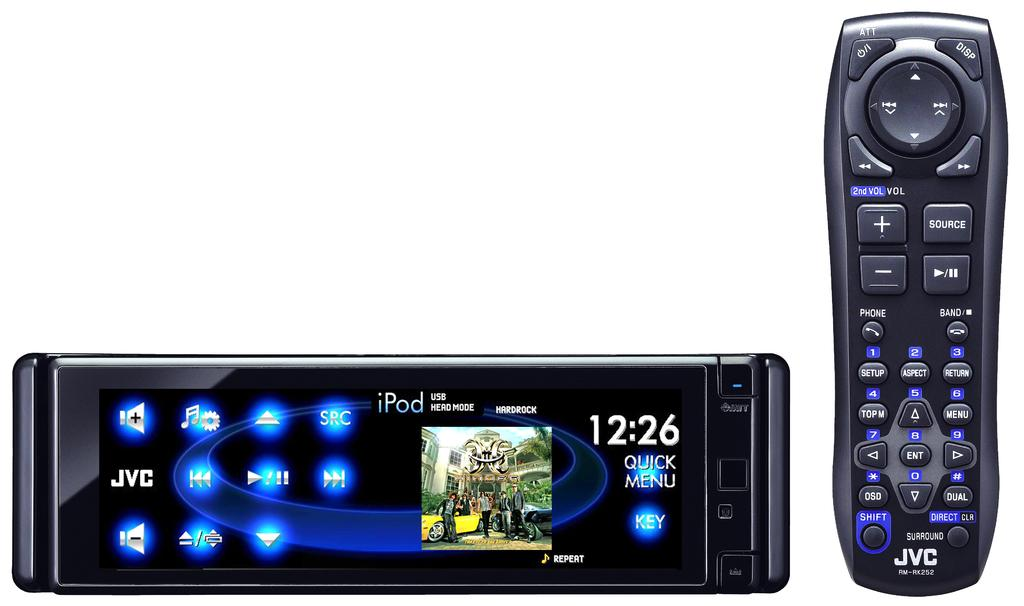<image>
Render a clear and concise summary of the photo. An old school JVC remote control has been placed next to a new model remote with a touch screen interface. 